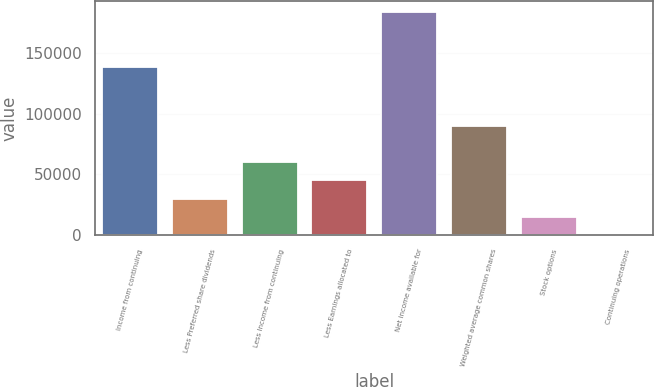Convert chart to OTSL. <chart><loc_0><loc_0><loc_500><loc_500><bar_chart><fcel>Income from continuing<fcel>Less Preferred share dividends<fcel>Less Income from continuing<fcel>Less Earnings allocated to<fcel>Net income available for<fcel>Weighted average common shares<fcel>Stock options<fcel>Continuing operations<nl><fcel>138679<fcel>30109.5<fcel>60216.9<fcel>45163.2<fcel>183840<fcel>90324.2<fcel>15055.9<fcel>2.17<nl></chart> 